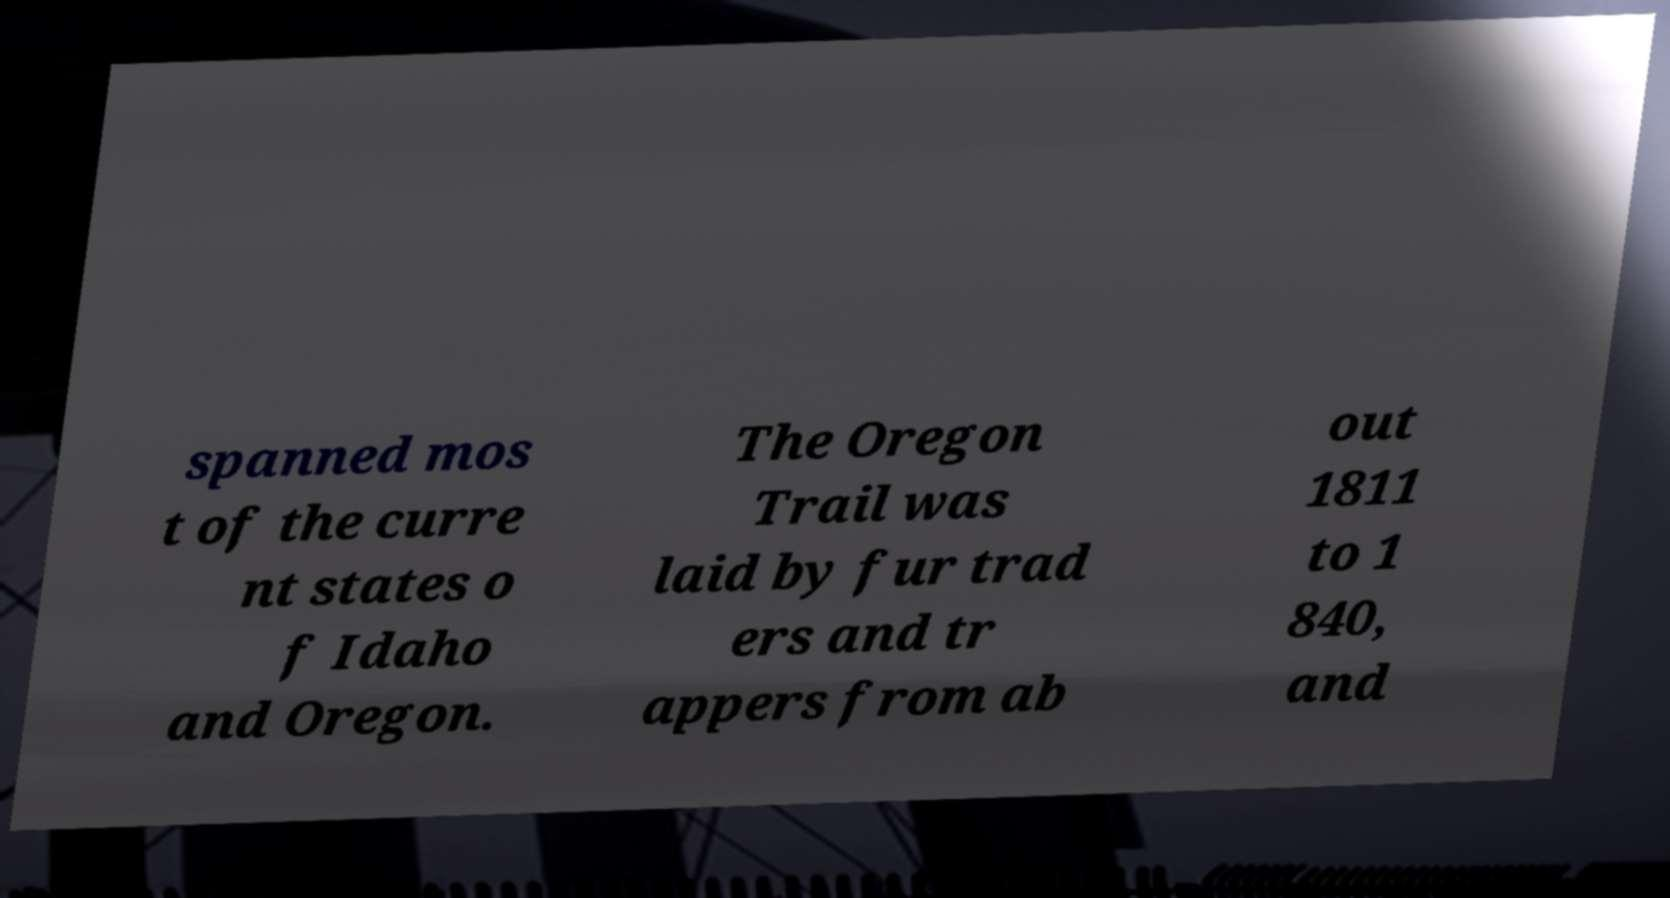Can you read and provide the text displayed in the image?This photo seems to have some interesting text. Can you extract and type it out for me? spanned mos t of the curre nt states o f Idaho and Oregon. The Oregon Trail was laid by fur trad ers and tr appers from ab out 1811 to 1 840, and 